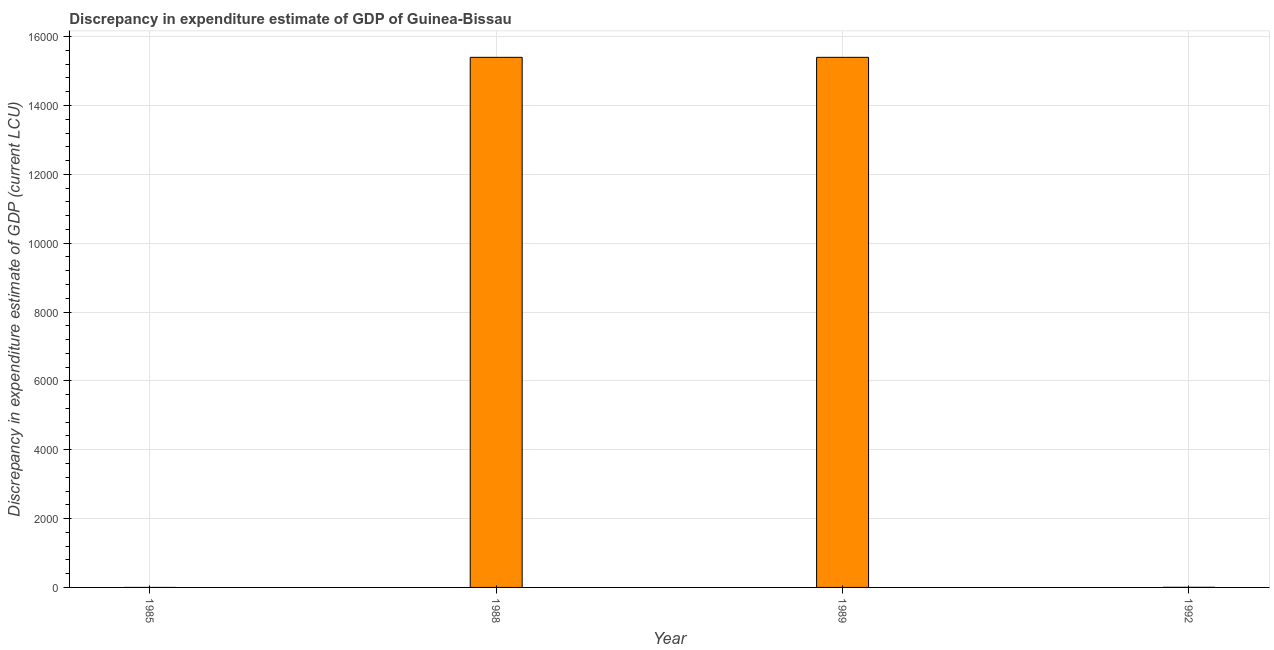Does the graph contain any zero values?
Keep it short and to the point. Yes. What is the title of the graph?
Offer a very short reply. Discrepancy in expenditure estimate of GDP of Guinea-Bissau. What is the label or title of the X-axis?
Make the answer very short. Year. What is the label or title of the Y-axis?
Give a very brief answer. Discrepancy in expenditure estimate of GDP (current LCU). What is the discrepancy in expenditure estimate of gdp in 1989?
Provide a succinct answer. 1.54e+04. Across all years, what is the maximum discrepancy in expenditure estimate of gdp?
Your answer should be compact. 1.54e+04. Across all years, what is the minimum discrepancy in expenditure estimate of gdp?
Your answer should be compact. 0. What is the sum of the discrepancy in expenditure estimate of gdp?
Your answer should be compact. 3.08e+04. What is the average discrepancy in expenditure estimate of gdp per year?
Provide a short and direct response. 7700. What is the median discrepancy in expenditure estimate of gdp?
Provide a succinct answer. 7700. Is the difference between the discrepancy in expenditure estimate of gdp in 1988 and 1989 greater than the difference between any two years?
Your answer should be compact. No. Is the sum of the discrepancy in expenditure estimate of gdp in 1988 and 1989 greater than the maximum discrepancy in expenditure estimate of gdp across all years?
Offer a terse response. Yes. What is the difference between the highest and the lowest discrepancy in expenditure estimate of gdp?
Offer a terse response. 1.54e+04. How many bars are there?
Make the answer very short. 2. Are all the bars in the graph horizontal?
Provide a short and direct response. No. What is the difference between two consecutive major ticks on the Y-axis?
Your response must be concise. 2000. What is the Discrepancy in expenditure estimate of GDP (current LCU) in 1985?
Ensure brevity in your answer.  0. What is the Discrepancy in expenditure estimate of GDP (current LCU) of 1988?
Ensure brevity in your answer.  1.54e+04. What is the Discrepancy in expenditure estimate of GDP (current LCU) of 1989?
Ensure brevity in your answer.  1.54e+04. 